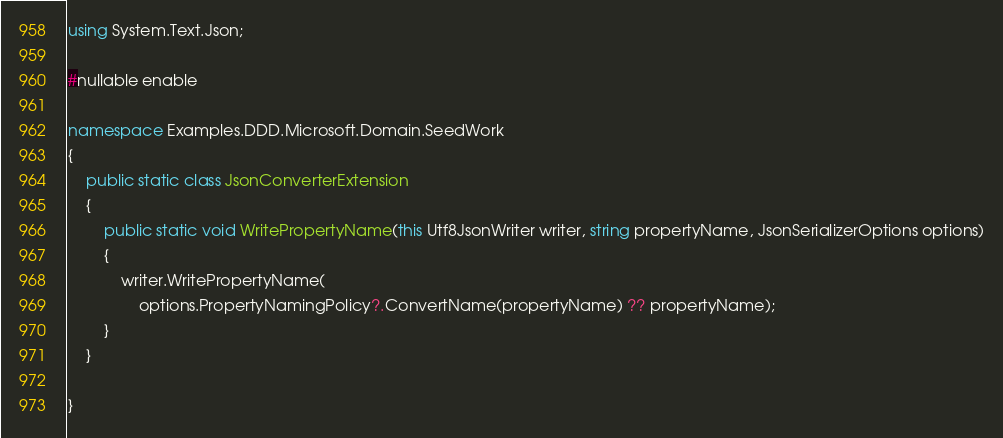Convert code to text. <code><loc_0><loc_0><loc_500><loc_500><_C#_>using System.Text.Json;

#nullable enable

namespace Examples.DDD.Microsoft.Domain.SeedWork
{
    public static class JsonConverterExtension
    {
        public static void WritePropertyName(this Utf8JsonWriter writer, string propertyName, JsonSerializerOptions options)
        {
            writer.WritePropertyName(
                options.PropertyNamingPolicy?.ConvertName(propertyName) ?? propertyName);
        }
    }

}
</code> 